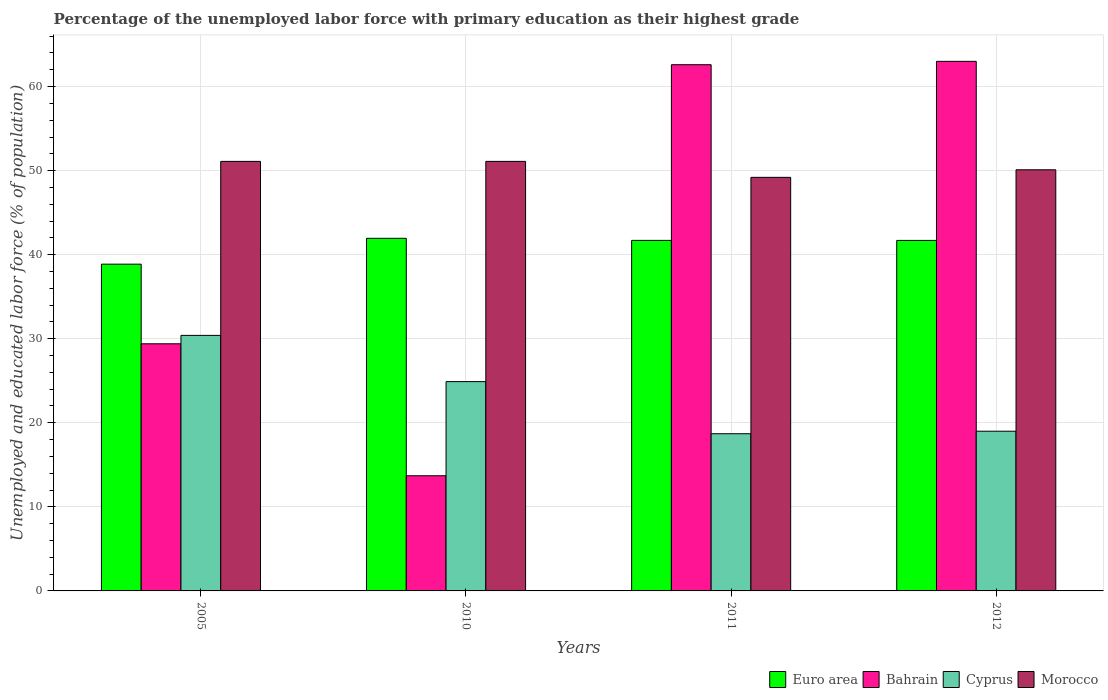How many different coloured bars are there?
Your answer should be compact. 4. How many groups of bars are there?
Give a very brief answer. 4. Are the number of bars on each tick of the X-axis equal?
Keep it short and to the point. Yes. How many bars are there on the 1st tick from the left?
Give a very brief answer. 4. In how many cases, is the number of bars for a given year not equal to the number of legend labels?
Provide a succinct answer. 0. What is the percentage of the unemployed labor force with primary education in Bahrain in 2005?
Your answer should be very brief. 29.4. Across all years, what is the minimum percentage of the unemployed labor force with primary education in Euro area?
Provide a short and direct response. 38.87. In which year was the percentage of the unemployed labor force with primary education in Bahrain maximum?
Keep it short and to the point. 2012. In which year was the percentage of the unemployed labor force with primary education in Cyprus minimum?
Your response must be concise. 2011. What is the total percentage of the unemployed labor force with primary education in Morocco in the graph?
Offer a terse response. 201.5. What is the difference between the percentage of the unemployed labor force with primary education in Cyprus in 2010 and that in 2011?
Make the answer very short. 6.2. What is the difference between the percentage of the unemployed labor force with primary education in Bahrain in 2011 and the percentage of the unemployed labor force with primary education in Cyprus in 2012?
Make the answer very short. 43.6. What is the average percentage of the unemployed labor force with primary education in Bahrain per year?
Ensure brevity in your answer.  42.17. In the year 2010, what is the difference between the percentage of the unemployed labor force with primary education in Bahrain and percentage of the unemployed labor force with primary education in Euro area?
Provide a short and direct response. -28.25. What is the ratio of the percentage of the unemployed labor force with primary education in Cyprus in 2005 to that in 2012?
Give a very brief answer. 1.6. What is the difference between the highest and the second highest percentage of the unemployed labor force with primary education in Bahrain?
Give a very brief answer. 0.4. What is the difference between the highest and the lowest percentage of the unemployed labor force with primary education in Euro area?
Your answer should be compact. 3.08. In how many years, is the percentage of the unemployed labor force with primary education in Euro area greater than the average percentage of the unemployed labor force with primary education in Euro area taken over all years?
Provide a succinct answer. 3. Is it the case that in every year, the sum of the percentage of the unemployed labor force with primary education in Bahrain and percentage of the unemployed labor force with primary education in Morocco is greater than the sum of percentage of the unemployed labor force with primary education in Euro area and percentage of the unemployed labor force with primary education in Cyprus?
Your answer should be very brief. No. What does the 4th bar from the left in 2011 represents?
Give a very brief answer. Morocco. What does the 2nd bar from the right in 2012 represents?
Your answer should be compact. Cyprus. Is it the case that in every year, the sum of the percentage of the unemployed labor force with primary education in Euro area and percentage of the unemployed labor force with primary education in Bahrain is greater than the percentage of the unemployed labor force with primary education in Cyprus?
Make the answer very short. Yes. Are the values on the major ticks of Y-axis written in scientific E-notation?
Your response must be concise. No. Does the graph contain grids?
Keep it short and to the point. Yes. Where does the legend appear in the graph?
Offer a very short reply. Bottom right. How many legend labels are there?
Give a very brief answer. 4. What is the title of the graph?
Keep it short and to the point. Percentage of the unemployed labor force with primary education as their highest grade. Does "Guyana" appear as one of the legend labels in the graph?
Offer a terse response. No. What is the label or title of the X-axis?
Offer a very short reply. Years. What is the label or title of the Y-axis?
Your answer should be very brief. Unemployed and educated labor force (% of population). What is the Unemployed and educated labor force (% of population) of Euro area in 2005?
Keep it short and to the point. 38.87. What is the Unemployed and educated labor force (% of population) of Bahrain in 2005?
Offer a terse response. 29.4. What is the Unemployed and educated labor force (% of population) of Cyprus in 2005?
Provide a succinct answer. 30.4. What is the Unemployed and educated labor force (% of population) in Morocco in 2005?
Provide a short and direct response. 51.1. What is the Unemployed and educated labor force (% of population) of Euro area in 2010?
Give a very brief answer. 41.95. What is the Unemployed and educated labor force (% of population) in Bahrain in 2010?
Make the answer very short. 13.7. What is the Unemployed and educated labor force (% of population) in Cyprus in 2010?
Provide a short and direct response. 24.9. What is the Unemployed and educated labor force (% of population) in Morocco in 2010?
Provide a succinct answer. 51.1. What is the Unemployed and educated labor force (% of population) in Euro area in 2011?
Keep it short and to the point. 41.7. What is the Unemployed and educated labor force (% of population) of Bahrain in 2011?
Offer a very short reply. 62.6. What is the Unemployed and educated labor force (% of population) of Cyprus in 2011?
Provide a short and direct response. 18.7. What is the Unemployed and educated labor force (% of population) in Morocco in 2011?
Offer a very short reply. 49.2. What is the Unemployed and educated labor force (% of population) in Euro area in 2012?
Your answer should be compact. 41.7. What is the Unemployed and educated labor force (% of population) in Morocco in 2012?
Provide a succinct answer. 50.1. Across all years, what is the maximum Unemployed and educated labor force (% of population) in Euro area?
Your answer should be compact. 41.95. Across all years, what is the maximum Unemployed and educated labor force (% of population) of Cyprus?
Your answer should be very brief. 30.4. Across all years, what is the maximum Unemployed and educated labor force (% of population) of Morocco?
Provide a succinct answer. 51.1. Across all years, what is the minimum Unemployed and educated labor force (% of population) in Euro area?
Provide a succinct answer. 38.87. Across all years, what is the minimum Unemployed and educated labor force (% of population) in Bahrain?
Offer a terse response. 13.7. Across all years, what is the minimum Unemployed and educated labor force (% of population) of Cyprus?
Provide a short and direct response. 18.7. Across all years, what is the minimum Unemployed and educated labor force (% of population) of Morocco?
Offer a terse response. 49.2. What is the total Unemployed and educated labor force (% of population) in Euro area in the graph?
Offer a very short reply. 164.22. What is the total Unemployed and educated labor force (% of population) in Bahrain in the graph?
Keep it short and to the point. 168.7. What is the total Unemployed and educated labor force (% of population) in Cyprus in the graph?
Your response must be concise. 93. What is the total Unemployed and educated labor force (% of population) of Morocco in the graph?
Provide a succinct answer. 201.5. What is the difference between the Unemployed and educated labor force (% of population) of Euro area in 2005 and that in 2010?
Offer a terse response. -3.08. What is the difference between the Unemployed and educated labor force (% of population) of Bahrain in 2005 and that in 2010?
Offer a terse response. 15.7. What is the difference between the Unemployed and educated labor force (% of population) in Morocco in 2005 and that in 2010?
Provide a succinct answer. 0. What is the difference between the Unemployed and educated labor force (% of population) in Euro area in 2005 and that in 2011?
Make the answer very short. -2.83. What is the difference between the Unemployed and educated labor force (% of population) in Bahrain in 2005 and that in 2011?
Ensure brevity in your answer.  -33.2. What is the difference between the Unemployed and educated labor force (% of population) of Cyprus in 2005 and that in 2011?
Offer a very short reply. 11.7. What is the difference between the Unemployed and educated labor force (% of population) in Morocco in 2005 and that in 2011?
Give a very brief answer. 1.9. What is the difference between the Unemployed and educated labor force (% of population) in Euro area in 2005 and that in 2012?
Give a very brief answer. -2.83. What is the difference between the Unemployed and educated labor force (% of population) of Bahrain in 2005 and that in 2012?
Your response must be concise. -33.6. What is the difference between the Unemployed and educated labor force (% of population) in Cyprus in 2005 and that in 2012?
Offer a terse response. 11.4. What is the difference between the Unemployed and educated labor force (% of population) of Morocco in 2005 and that in 2012?
Your answer should be very brief. 1. What is the difference between the Unemployed and educated labor force (% of population) in Euro area in 2010 and that in 2011?
Make the answer very short. 0.25. What is the difference between the Unemployed and educated labor force (% of population) of Bahrain in 2010 and that in 2011?
Provide a succinct answer. -48.9. What is the difference between the Unemployed and educated labor force (% of population) of Cyprus in 2010 and that in 2011?
Your response must be concise. 6.2. What is the difference between the Unemployed and educated labor force (% of population) of Euro area in 2010 and that in 2012?
Ensure brevity in your answer.  0.25. What is the difference between the Unemployed and educated labor force (% of population) of Bahrain in 2010 and that in 2012?
Give a very brief answer. -49.3. What is the difference between the Unemployed and educated labor force (% of population) of Morocco in 2010 and that in 2012?
Your response must be concise. 1. What is the difference between the Unemployed and educated labor force (% of population) of Euro area in 2011 and that in 2012?
Offer a terse response. 0. What is the difference between the Unemployed and educated labor force (% of population) of Bahrain in 2011 and that in 2012?
Give a very brief answer. -0.4. What is the difference between the Unemployed and educated labor force (% of population) in Euro area in 2005 and the Unemployed and educated labor force (% of population) in Bahrain in 2010?
Keep it short and to the point. 25.17. What is the difference between the Unemployed and educated labor force (% of population) in Euro area in 2005 and the Unemployed and educated labor force (% of population) in Cyprus in 2010?
Ensure brevity in your answer.  13.97. What is the difference between the Unemployed and educated labor force (% of population) in Euro area in 2005 and the Unemployed and educated labor force (% of population) in Morocco in 2010?
Your response must be concise. -12.23. What is the difference between the Unemployed and educated labor force (% of population) in Bahrain in 2005 and the Unemployed and educated labor force (% of population) in Morocco in 2010?
Your answer should be compact. -21.7. What is the difference between the Unemployed and educated labor force (% of population) of Cyprus in 2005 and the Unemployed and educated labor force (% of population) of Morocco in 2010?
Ensure brevity in your answer.  -20.7. What is the difference between the Unemployed and educated labor force (% of population) of Euro area in 2005 and the Unemployed and educated labor force (% of population) of Bahrain in 2011?
Make the answer very short. -23.73. What is the difference between the Unemployed and educated labor force (% of population) in Euro area in 2005 and the Unemployed and educated labor force (% of population) in Cyprus in 2011?
Offer a terse response. 20.17. What is the difference between the Unemployed and educated labor force (% of population) of Euro area in 2005 and the Unemployed and educated labor force (% of population) of Morocco in 2011?
Give a very brief answer. -10.33. What is the difference between the Unemployed and educated labor force (% of population) in Bahrain in 2005 and the Unemployed and educated labor force (% of population) in Morocco in 2011?
Your response must be concise. -19.8. What is the difference between the Unemployed and educated labor force (% of population) in Cyprus in 2005 and the Unemployed and educated labor force (% of population) in Morocco in 2011?
Provide a short and direct response. -18.8. What is the difference between the Unemployed and educated labor force (% of population) of Euro area in 2005 and the Unemployed and educated labor force (% of population) of Bahrain in 2012?
Your answer should be very brief. -24.13. What is the difference between the Unemployed and educated labor force (% of population) in Euro area in 2005 and the Unemployed and educated labor force (% of population) in Cyprus in 2012?
Offer a very short reply. 19.87. What is the difference between the Unemployed and educated labor force (% of population) in Euro area in 2005 and the Unemployed and educated labor force (% of population) in Morocco in 2012?
Your answer should be compact. -11.23. What is the difference between the Unemployed and educated labor force (% of population) in Bahrain in 2005 and the Unemployed and educated labor force (% of population) in Morocco in 2012?
Give a very brief answer. -20.7. What is the difference between the Unemployed and educated labor force (% of population) of Cyprus in 2005 and the Unemployed and educated labor force (% of population) of Morocco in 2012?
Offer a very short reply. -19.7. What is the difference between the Unemployed and educated labor force (% of population) of Euro area in 2010 and the Unemployed and educated labor force (% of population) of Bahrain in 2011?
Provide a succinct answer. -20.65. What is the difference between the Unemployed and educated labor force (% of population) of Euro area in 2010 and the Unemployed and educated labor force (% of population) of Cyprus in 2011?
Your response must be concise. 23.25. What is the difference between the Unemployed and educated labor force (% of population) in Euro area in 2010 and the Unemployed and educated labor force (% of population) in Morocco in 2011?
Make the answer very short. -7.25. What is the difference between the Unemployed and educated labor force (% of population) in Bahrain in 2010 and the Unemployed and educated labor force (% of population) in Cyprus in 2011?
Keep it short and to the point. -5. What is the difference between the Unemployed and educated labor force (% of population) of Bahrain in 2010 and the Unemployed and educated labor force (% of population) of Morocco in 2011?
Keep it short and to the point. -35.5. What is the difference between the Unemployed and educated labor force (% of population) in Cyprus in 2010 and the Unemployed and educated labor force (% of population) in Morocco in 2011?
Your response must be concise. -24.3. What is the difference between the Unemployed and educated labor force (% of population) of Euro area in 2010 and the Unemployed and educated labor force (% of population) of Bahrain in 2012?
Offer a terse response. -21.05. What is the difference between the Unemployed and educated labor force (% of population) in Euro area in 2010 and the Unemployed and educated labor force (% of population) in Cyprus in 2012?
Keep it short and to the point. 22.95. What is the difference between the Unemployed and educated labor force (% of population) of Euro area in 2010 and the Unemployed and educated labor force (% of population) of Morocco in 2012?
Provide a succinct answer. -8.15. What is the difference between the Unemployed and educated labor force (% of population) of Bahrain in 2010 and the Unemployed and educated labor force (% of population) of Cyprus in 2012?
Your response must be concise. -5.3. What is the difference between the Unemployed and educated labor force (% of population) of Bahrain in 2010 and the Unemployed and educated labor force (% of population) of Morocco in 2012?
Provide a short and direct response. -36.4. What is the difference between the Unemployed and educated labor force (% of population) of Cyprus in 2010 and the Unemployed and educated labor force (% of population) of Morocco in 2012?
Offer a terse response. -25.2. What is the difference between the Unemployed and educated labor force (% of population) of Euro area in 2011 and the Unemployed and educated labor force (% of population) of Bahrain in 2012?
Offer a very short reply. -21.3. What is the difference between the Unemployed and educated labor force (% of population) of Euro area in 2011 and the Unemployed and educated labor force (% of population) of Cyprus in 2012?
Provide a succinct answer. 22.7. What is the difference between the Unemployed and educated labor force (% of population) in Euro area in 2011 and the Unemployed and educated labor force (% of population) in Morocco in 2012?
Offer a terse response. -8.4. What is the difference between the Unemployed and educated labor force (% of population) in Bahrain in 2011 and the Unemployed and educated labor force (% of population) in Cyprus in 2012?
Make the answer very short. 43.6. What is the difference between the Unemployed and educated labor force (% of population) in Bahrain in 2011 and the Unemployed and educated labor force (% of population) in Morocco in 2012?
Provide a short and direct response. 12.5. What is the difference between the Unemployed and educated labor force (% of population) in Cyprus in 2011 and the Unemployed and educated labor force (% of population) in Morocco in 2012?
Your answer should be compact. -31.4. What is the average Unemployed and educated labor force (% of population) of Euro area per year?
Provide a succinct answer. 41.06. What is the average Unemployed and educated labor force (% of population) of Bahrain per year?
Provide a short and direct response. 42.17. What is the average Unemployed and educated labor force (% of population) of Cyprus per year?
Keep it short and to the point. 23.25. What is the average Unemployed and educated labor force (% of population) of Morocco per year?
Offer a terse response. 50.38. In the year 2005, what is the difference between the Unemployed and educated labor force (% of population) of Euro area and Unemployed and educated labor force (% of population) of Bahrain?
Offer a very short reply. 9.47. In the year 2005, what is the difference between the Unemployed and educated labor force (% of population) of Euro area and Unemployed and educated labor force (% of population) of Cyprus?
Offer a terse response. 8.47. In the year 2005, what is the difference between the Unemployed and educated labor force (% of population) of Euro area and Unemployed and educated labor force (% of population) of Morocco?
Provide a short and direct response. -12.23. In the year 2005, what is the difference between the Unemployed and educated labor force (% of population) in Bahrain and Unemployed and educated labor force (% of population) in Cyprus?
Your answer should be very brief. -1. In the year 2005, what is the difference between the Unemployed and educated labor force (% of population) in Bahrain and Unemployed and educated labor force (% of population) in Morocco?
Provide a succinct answer. -21.7. In the year 2005, what is the difference between the Unemployed and educated labor force (% of population) in Cyprus and Unemployed and educated labor force (% of population) in Morocco?
Your answer should be compact. -20.7. In the year 2010, what is the difference between the Unemployed and educated labor force (% of population) in Euro area and Unemployed and educated labor force (% of population) in Bahrain?
Your answer should be compact. 28.25. In the year 2010, what is the difference between the Unemployed and educated labor force (% of population) of Euro area and Unemployed and educated labor force (% of population) of Cyprus?
Keep it short and to the point. 17.05. In the year 2010, what is the difference between the Unemployed and educated labor force (% of population) of Euro area and Unemployed and educated labor force (% of population) of Morocco?
Offer a very short reply. -9.15. In the year 2010, what is the difference between the Unemployed and educated labor force (% of population) of Bahrain and Unemployed and educated labor force (% of population) of Morocco?
Provide a short and direct response. -37.4. In the year 2010, what is the difference between the Unemployed and educated labor force (% of population) in Cyprus and Unemployed and educated labor force (% of population) in Morocco?
Keep it short and to the point. -26.2. In the year 2011, what is the difference between the Unemployed and educated labor force (% of population) of Euro area and Unemployed and educated labor force (% of population) of Bahrain?
Make the answer very short. -20.9. In the year 2011, what is the difference between the Unemployed and educated labor force (% of population) in Euro area and Unemployed and educated labor force (% of population) in Cyprus?
Your answer should be very brief. 23. In the year 2011, what is the difference between the Unemployed and educated labor force (% of population) of Euro area and Unemployed and educated labor force (% of population) of Morocco?
Offer a terse response. -7.5. In the year 2011, what is the difference between the Unemployed and educated labor force (% of population) of Bahrain and Unemployed and educated labor force (% of population) of Cyprus?
Offer a terse response. 43.9. In the year 2011, what is the difference between the Unemployed and educated labor force (% of population) of Cyprus and Unemployed and educated labor force (% of population) of Morocco?
Provide a short and direct response. -30.5. In the year 2012, what is the difference between the Unemployed and educated labor force (% of population) of Euro area and Unemployed and educated labor force (% of population) of Bahrain?
Offer a very short reply. -21.3. In the year 2012, what is the difference between the Unemployed and educated labor force (% of population) in Euro area and Unemployed and educated labor force (% of population) in Cyprus?
Ensure brevity in your answer.  22.7. In the year 2012, what is the difference between the Unemployed and educated labor force (% of population) of Euro area and Unemployed and educated labor force (% of population) of Morocco?
Ensure brevity in your answer.  -8.4. In the year 2012, what is the difference between the Unemployed and educated labor force (% of population) in Bahrain and Unemployed and educated labor force (% of population) in Cyprus?
Make the answer very short. 44. In the year 2012, what is the difference between the Unemployed and educated labor force (% of population) in Cyprus and Unemployed and educated labor force (% of population) in Morocco?
Your answer should be compact. -31.1. What is the ratio of the Unemployed and educated labor force (% of population) in Euro area in 2005 to that in 2010?
Provide a short and direct response. 0.93. What is the ratio of the Unemployed and educated labor force (% of population) in Bahrain in 2005 to that in 2010?
Your answer should be compact. 2.15. What is the ratio of the Unemployed and educated labor force (% of population) of Cyprus in 2005 to that in 2010?
Keep it short and to the point. 1.22. What is the ratio of the Unemployed and educated labor force (% of population) of Euro area in 2005 to that in 2011?
Provide a short and direct response. 0.93. What is the ratio of the Unemployed and educated labor force (% of population) in Bahrain in 2005 to that in 2011?
Ensure brevity in your answer.  0.47. What is the ratio of the Unemployed and educated labor force (% of population) in Cyprus in 2005 to that in 2011?
Provide a succinct answer. 1.63. What is the ratio of the Unemployed and educated labor force (% of population) in Morocco in 2005 to that in 2011?
Keep it short and to the point. 1.04. What is the ratio of the Unemployed and educated labor force (% of population) in Euro area in 2005 to that in 2012?
Offer a terse response. 0.93. What is the ratio of the Unemployed and educated labor force (% of population) in Bahrain in 2005 to that in 2012?
Provide a succinct answer. 0.47. What is the ratio of the Unemployed and educated labor force (% of population) in Cyprus in 2005 to that in 2012?
Give a very brief answer. 1.6. What is the ratio of the Unemployed and educated labor force (% of population) in Morocco in 2005 to that in 2012?
Your response must be concise. 1.02. What is the ratio of the Unemployed and educated labor force (% of population) in Euro area in 2010 to that in 2011?
Provide a short and direct response. 1.01. What is the ratio of the Unemployed and educated labor force (% of population) of Bahrain in 2010 to that in 2011?
Provide a short and direct response. 0.22. What is the ratio of the Unemployed and educated labor force (% of population) of Cyprus in 2010 to that in 2011?
Keep it short and to the point. 1.33. What is the ratio of the Unemployed and educated labor force (% of population) in Morocco in 2010 to that in 2011?
Provide a succinct answer. 1.04. What is the ratio of the Unemployed and educated labor force (% of population) of Bahrain in 2010 to that in 2012?
Your response must be concise. 0.22. What is the ratio of the Unemployed and educated labor force (% of population) of Cyprus in 2010 to that in 2012?
Your answer should be very brief. 1.31. What is the ratio of the Unemployed and educated labor force (% of population) in Morocco in 2010 to that in 2012?
Give a very brief answer. 1.02. What is the ratio of the Unemployed and educated labor force (% of population) in Euro area in 2011 to that in 2012?
Make the answer very short. 1. What is the ratio of the Unemployed and educated labor force (% of population) of Bahrain in 2011 to that in 2012?
Ensure brevity in your answer.  0.99. What is the ratio of the Unemployed and educated labor force (% of population) of Cyprus in 2011 to that in 2012?
Make the answer very short. 0.98. What is the difference between the highest and the second highest Unemployed and educated labor force (% of population) in Euro area?
Your response must be concise. 0.25. What is the difference between the highest and the second highest Unemployed and educated labor force (% of population) of Bahrain?
Offer a terse response. 0.4. What is the difference between the highest and the lowest Unemployed and educated labor force (% of population) of Euro area?
Make the answer very short. 3.08. What is the difference between the highest and the lowest Unemployed and educated labor force (% of population) in Bahrain?
Your answer should be very brief. 49.3. 